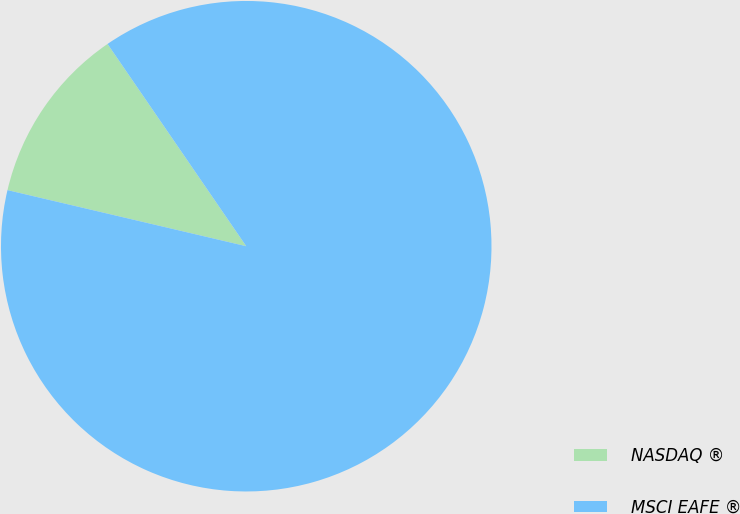Convert chart. <chart><loc_0><loc_0><loc_500><loc_500><pie_chart><fcel>NASDAQ ®<fcel>MSCI EAFE ®<nl><fcel>11.76%<fcel>88.24%<nl></chart> 